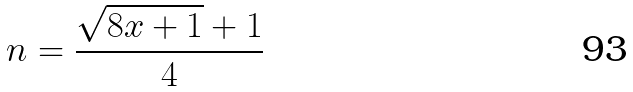<formula> <loc_0><loc_0><loc_500><loc_500>n = \frac { \sqrt { 8 x + 1 } + 1 } { 4 }</formula> 